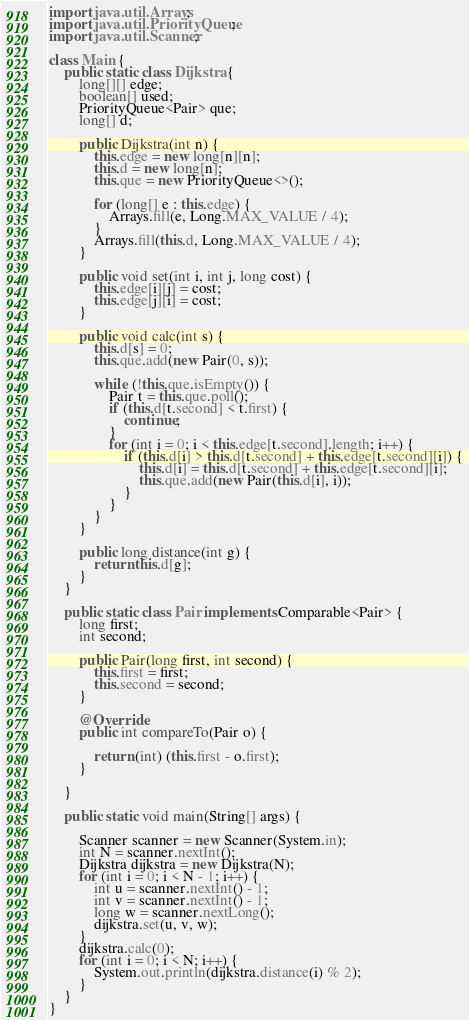Convert code to text. <code><loc_0><loc_0><loc_500><loc_500><_Java_>import java.util.Arrays;
import java.util.PriorityQueue;
import java.util.Scanner;

class Main {
    public static class Dijkstra {
        long[][] edge;
        boolean[] used;
        PriorityQueue<Pair> que;
        long[] d;

        public Dijkstra(int n) {
            this.edge = new long[n][n];
            this.d = new long[n];
            this.que = new PriorityQueue<>();

            for (long[] e : this.edge) {
                Arrays.fill(e, Long.MAX_VALUE / 4);
            }
            Arrays.fill(this.d, Long.MAX_VALUE / 4);
        }

        public void set(int i, int j, long cost) {
            this.edge[i][j] = cost;
            this.edge[j][i] = cost;
        }

        public void calc(int s) {
            this.d[s] = 0;
            this.que.add(new Pair(0, s));

            while (!this.que.isEmpty()) {
                Pair t = this.que.poll();
                if (this.d[t.second] < t.first) {
                    continue;
                }
                for (int i = 0; i < this.edge[t.second].length; i++) {
                    if (this.d[i] > this.d[t.second] + this.edge[t.second][i]) {
                        this.d[i] = this.d[t.second] + this.edge[t.second][i];
                        this.que.add(new Pair(this.d[i], i));
                    }
                }
            }
        }

        public long distance(int g) {
            return this.d[g];
        }
    }

    public static class Pair implements Comparable<Pair> {
        long first;
        int second;

        public Pair(long first, int second) {
            this.first = first;
            this.second = second;
        }

        @Override
        public int compareTo(Pair o) {

            return (int) (this.first - o.first);
        }

    }

    public static void main(String[] args) {

        Scanner scanner = new Scanner(System.in);
        int N = scanner.nextInt();
        Dijkstra dijkstra = new Dijkstra(N);
        for (int i = 0; i < N - 1; i++) {
            int u = scanner.nextInt() - 1;
            int v = scanner.nextInt() - 1;
            long w = scanner.nextLong();
            dijkstra.set(u, v, w);
        }
        dijkstra.calc(0);
        for (int i = 0; i < N; i++) {
            System.out.println(dijkstra.distance(i) % 2);
        }
    }
}
</code> 